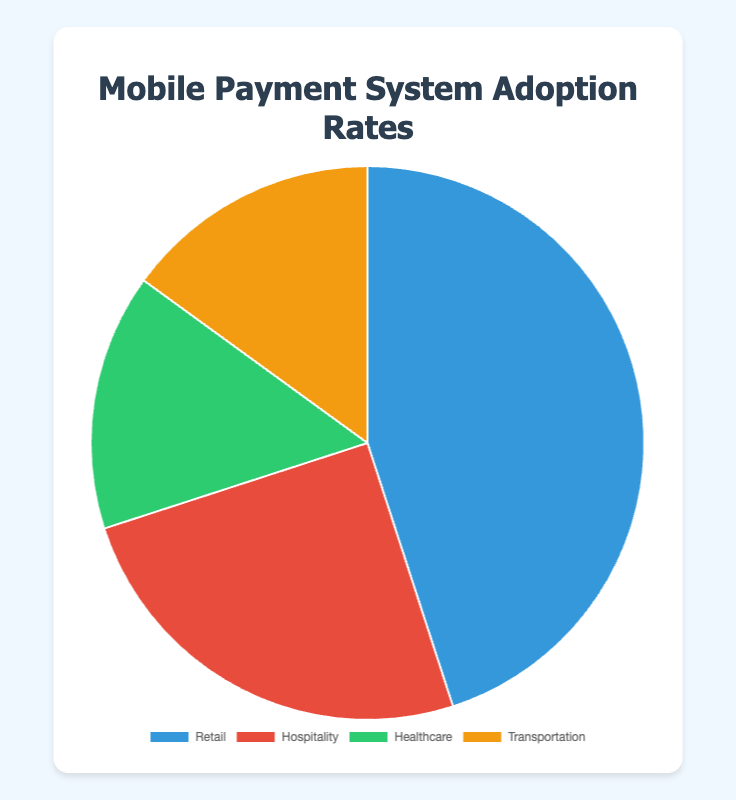What's the adoption rate of the Retail industry? To find the Retail industry's adoption rate, refer to the section of the pie chart labeled "Retail". The label shows that the adoption rate is 45%, indicating Retail has the highest adoption among the listed industries.
Answer: 45% Which industry has the lowest adoption rate? To determine the industry with the lowest adoption rate, compare the percentages shown for each industry in the pie chart. Both Healthcare and Transportation have the lowest adoption rate, each at 15%.
Answer: Healthcare and Transportation What is the combined adoption rate of Healthcare and Transportation industries? To calculate the combined adoption rate of Healthcare and Transportation, add their respective adoption rates. Healthcare has an adoption rate of 15%, and Transportation also has 15%, so the combined rate is 15% + 15% = 30%.
Answer: 30% How does the adoption rate of Hospitality compare to Transportation? Compare the Hospitality and Transportation sections of the pie chart. Hospitality has an adoption rate of 25%, while Transportation has 15%. Thus, Hospitality has a higher adoption rate.
Answer: Hospitality has a higher adoption rate What is the average adoption rate across all industries? To find the average adoption rate, sum the adoption rates of all industries and divide by the number of industries. The adoption rates are 45% (Retail), 25% (Hospitality), 15% (Healthcare), and 15% (Transportation). The total is 45% + 25% + 15% + 15% = 100%. There are 4 industries, so the average is 100% / 4 = 25%.
Answer: 25% By how much does the Retail adoption rate exceed the Healthcare adoption rate? To determine the difference between Retail and Healthcare adoption rates, subtract the Healthcare rate from the Retail rate. The Retail rate is 45%, and the Healthcare rate is 15%, so the difference is 45% - 15% = 30%.
Answer: 30% What is the proportion of the pie chart occupied by the Hospitality industry? To identify the portion of the pie chart taken up by the Hospitality industry, look at its adoption rate. Hospitality occupies 25% of the chart, meaning its sector visually represents 25% of the pie chart.
Answer: 25% Is the combined adoption rate of Healthcare and Hospitality greater than that of Retail? First, find the combined adoption rates for Healthcare and Hospitality by summing their adoption rates (15% + 25% = 40%). Then, compare this sum with the Retail adoption rate (45%). Since 40% is less than 45%, the combined rate is not greater than Retail's.
Answer: No Which industry uses the color blue in the pie chart? Check the color assignments in the chart's legend or sections to identify which industry is represented by blue. The Retail industry uses the color blue.
Answer: Retail 